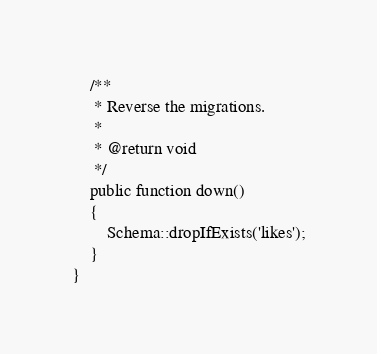Convert code to text. <code><loc_0><loc_0><loc_500><loc_500><_PHP_>
    /**
     * Reverse the migrations.
     *
     * @return void
     */
    public function down()
    {
        Schema::dropIfExists('likes');
    }
}
</code> 